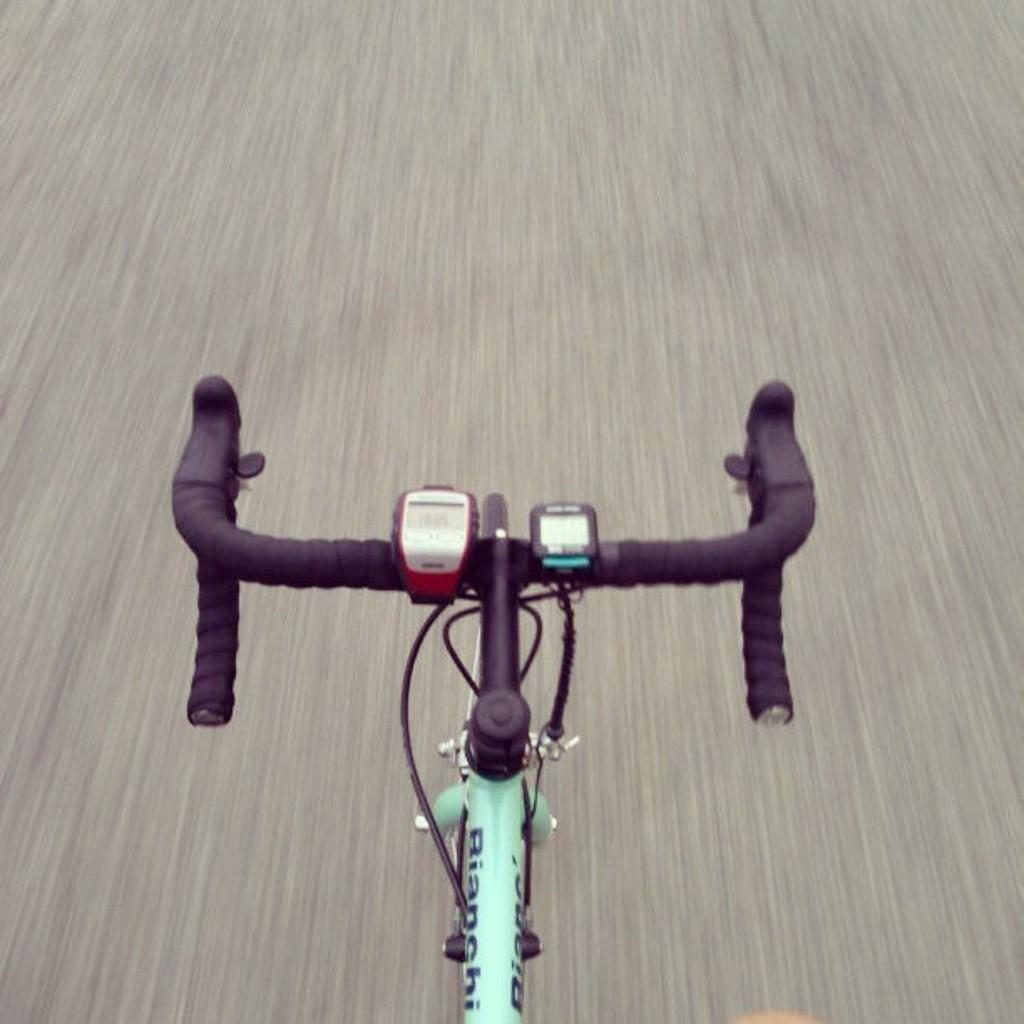What part of a bicycle can be seen in the image? There is a handlebar and a supporting rod of a bicycle in the image. What is located at the bottom of the image? The image shows a road at the bottom. What is attached to the handlebar in the image? There are two digital displays attached to the handlebar. What type of waves can be seen crashing on the shore in the image? There are no waves or shore visible in the image; it shows a handlebar, supporting rod, road, and digital displays. 